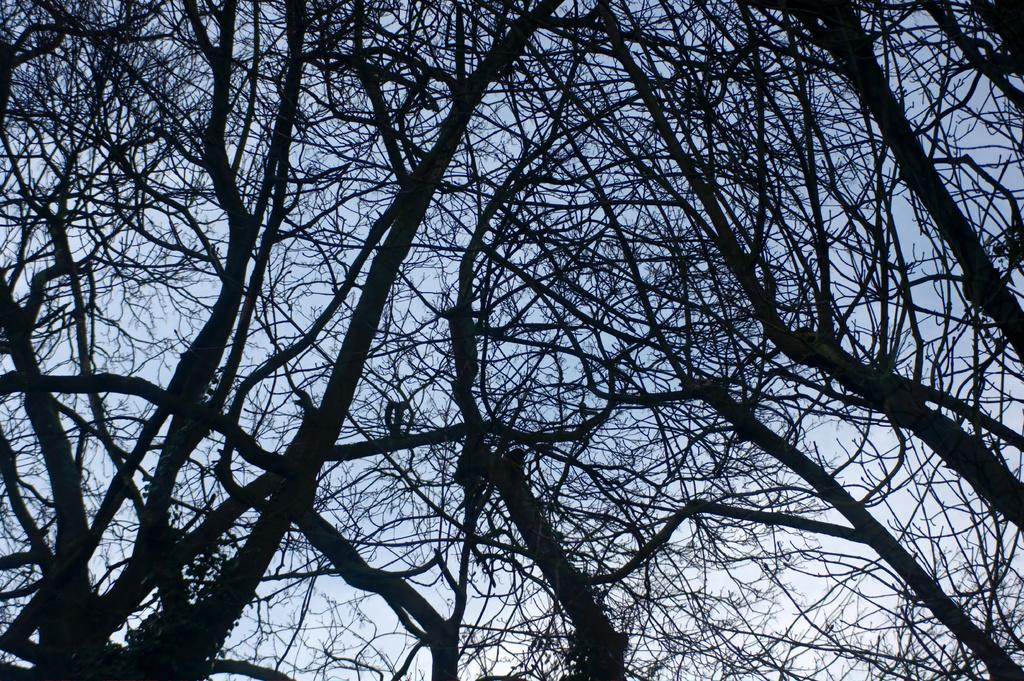What type of trees are visible in the image? There are bare trees in the image. What can be seen in the background of the image? There is sky visible in the background of the image. How many pins are attached to the trees in the image? There are no pins present in the image; it only features bare trees and sky. What type of bikes can be seen in the image? There are no bikes present in the image; it only features bare trees and sky. 